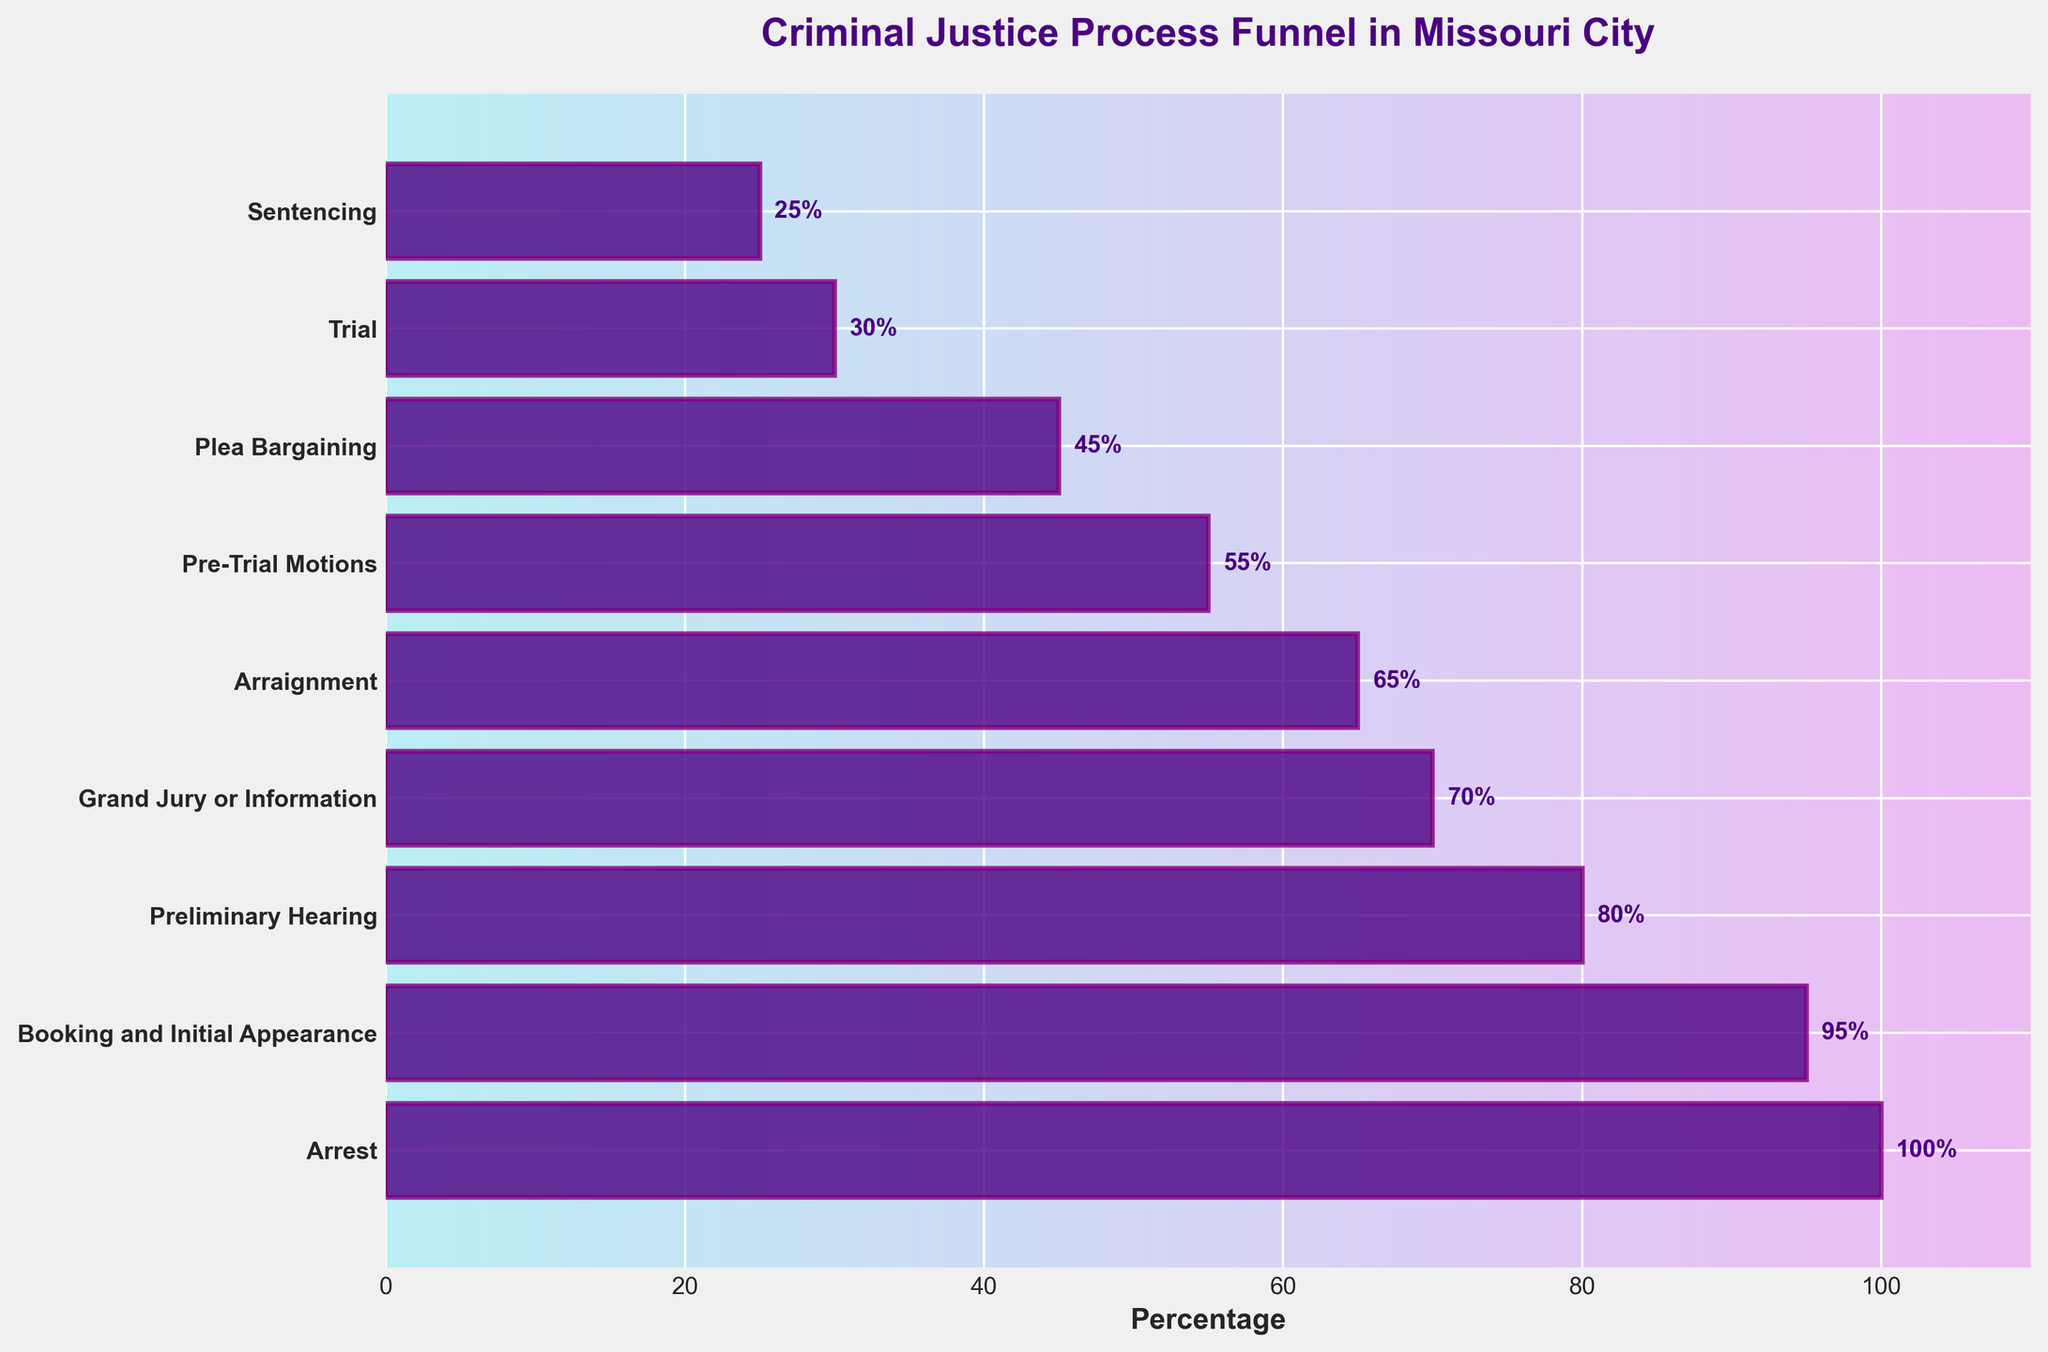What is the title of the funnel chart? The title is typically displayed at the top of the chart. Here, the title is clearly visible and states the main subject of the chart.
Answer: Criminal Justice Process Funnel in Missouri City How many stages are listed in the funnel chart? The stages are marked by the horizontal bars, each representing a different part of the process. Counting these bars gives the total number of stages.
Answer: 9 Which stage sees the biggest drop in percentage from its previous stage? To find this, we subtract the percentages of each stage from the one preceding it, and identify the largest difference. Biggest drop is from 80% (Preliminary Hearing) to 70% (Grand Jury or Information), a drop of 10%.
Answer: Preliminary Hearing to Grand Jury or Information What is the percentage of cases that reach the sentencing stage? This is located at the end of the funnel and is labeled directly on the bar for Sentencing stage.
Answer: 25% How does the percentage drop from Plea Bargaining to Trial compare to the percentage drop from Arraignment to Pre-Trial Motions? Calculate the drop for both stages: Plea Bargaining to Trial (from 45% to 30%), a drop of 15%. Arraignment to Pre-Trial Motions (from 65% to 55%), a drop of 10%. Then compare these.
Answer: Larger drop from Plea Bargaining to Trial What stage comes after Booking and Initial Appearance? This can be determined by looking at the sequential order of the stages from top to bottom. The stage immediately following Booking and Initial Appearance is Preliminary Hearing.
Answer: Preliminary Hearing If 1000 cases start at the arrest stage, how many cases approximately reach the Trial stage? Using the given percentages, calculate: 1000 cases * 30% (since Trial is at 30% of the cases remaining).
Answer: 300 Which stage directly precedes Sentencing? Look at the stages listed before Sentencing to find the one directly above it in the funnel chart.
Answer: Trial Which stages have more than 50% of the cases continuing to the next stage? By reviewing the percentages, stages with more than 50% are: Arrest, Booking and Initial Appearance, Preliminary Hearing, Grand Jury or Information, Arraignment, Pre-Trial Motions, and Plea Bargaining.
Answer: 7 stages At which stage does the percentage drop below 50% for the first time? This is the first stage in the funnel where the percentage of cases drops to less than 50%. It happens at the Plea Bargaining stage where it drops to 45%.
Answer: Plea Bargaining 